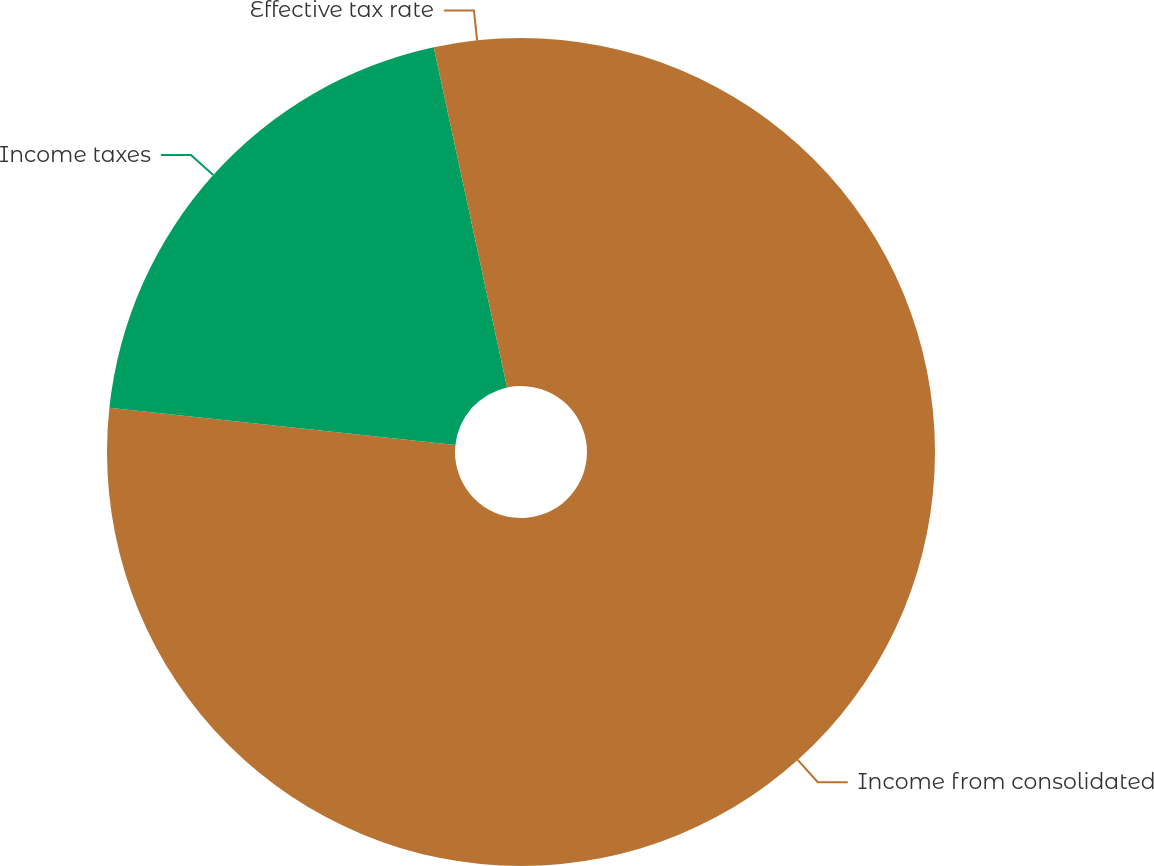<chart> <loc_0><loc_0><loc_500><loc_500><pie_chart><fcel>Income from consolidated<fcel>Income taxes<fcel>Effective tax rate<nl><fcel>76.7%<fcel>19.92%<fcel>3.38%<nl></chart> 